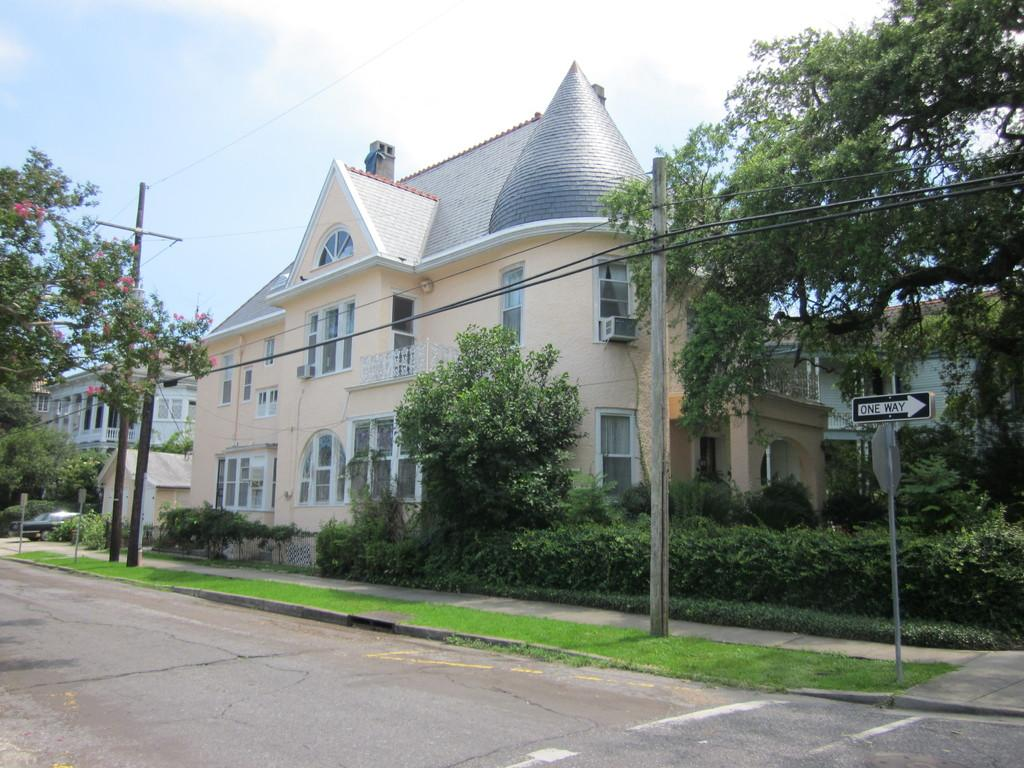What is the main feature of the image? There is a road in the image. What else can be seen along the road? There are poles, wires, and a board in the image. What type of vegetation is present in the image? There are trees and pink flowers in the image. What can be seen in the background of the image? There are buildings, a car, and the sky visible in the background of the image. What type of sugar is being used to sweeten the birthday cake in the image? There is no birthday cake or sugar present in the image. Is there a gun visible in the image? No, there is no gun visible in the image. 